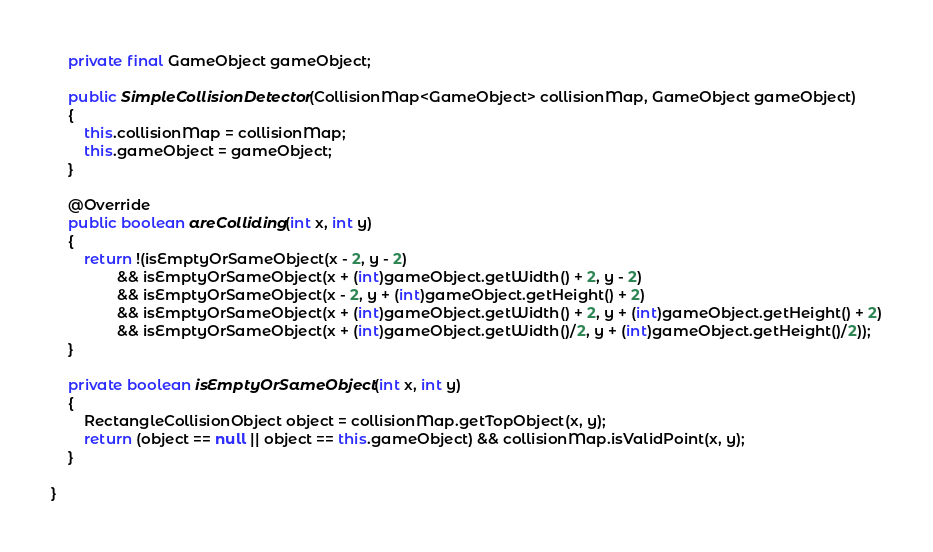Convert code to text. <code><loc_0><loc_0><loc_500><loc_500><_Java_>	private final GameObject gameObject;

	public SimpleCollisionDetector(CollisionMap<GameObject> collisionMap, GameObject gameObject)
	{
		this.collisionMap = collisionMap;
		this.gameObject = gameObject;
	}

	@Override
	public boolean areColliding(int x, int y)
	{
		return !(isEmptyOrSameObject(x - 2, y - 2)
				&& isEmptyOrSameObject(x + (int)gameObject.getWidth() + 2, y - 2)
				&& isEmptyOrSameObject(x - 2, y + (int)gameObject.getHeight() + 2)
				&& isEmptyOrSameObject(x + (int)gameObject.getWidth() + 2, y + (int)gameObject.getHeight() + 2)
				&& isEmptyOrSameObject(x + (int)gameObject.getWidth()/2, y + (int)gameObject.getHeight()/2));
	}

	private boolean isEmptyOrSameObject(int x, int y)
	{
		RectangleCollisionObject object = collisionMap.getTopObject(x, y);
		return (object == null || object == this.gameObject) && collisionMap.isValidPoint(x, y);
	}

}
</code> 